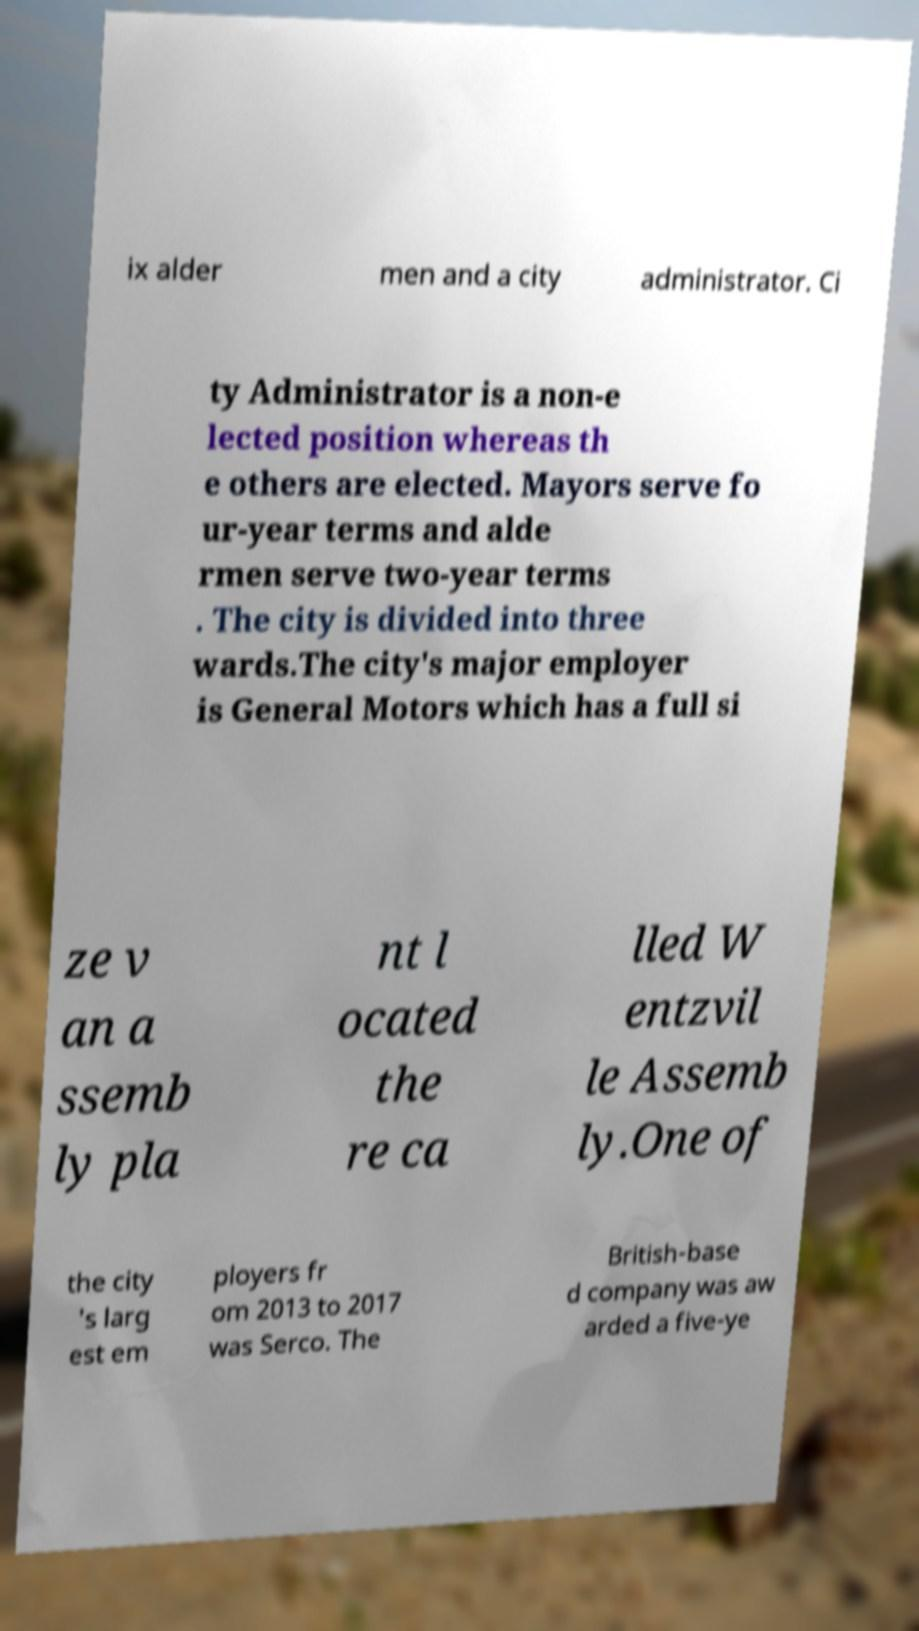What messages or text are displayed in this image? I need them in a readable, typed format. ix alder men and a city administrator. Ci ty Administrator is a non-e lected position whereas th e others are elected. Mayors serve fo ur-year terms and alde rmen serve two-year terms . The city is divided into three wards.The city's major employer is General Motors which has a full si ze v an a ssemb ly pla nt l ocated the re ca lled W entzvil le Assemb ly.One of the city 's larg est em ployers fr om 2013 to 2017 was Serco. The British-base d company was aw arded a five-ye 